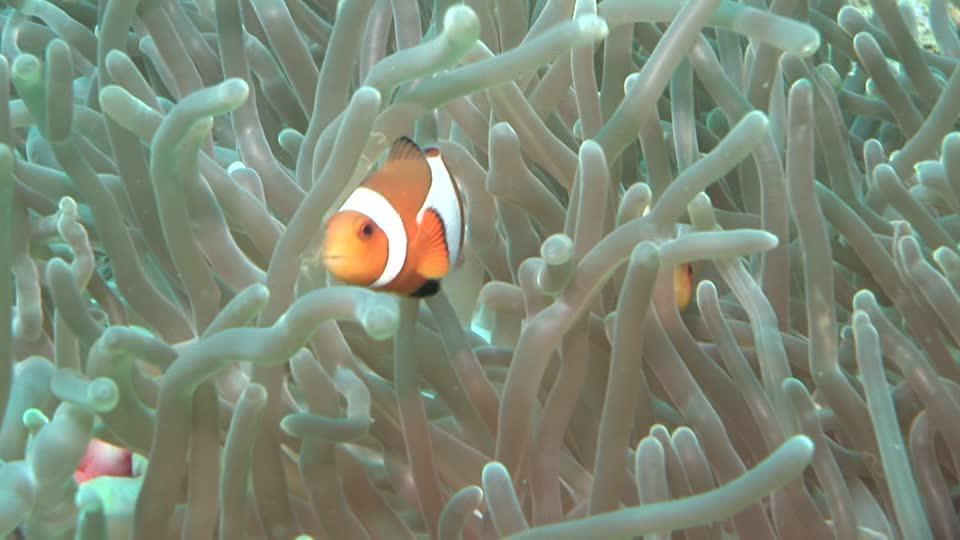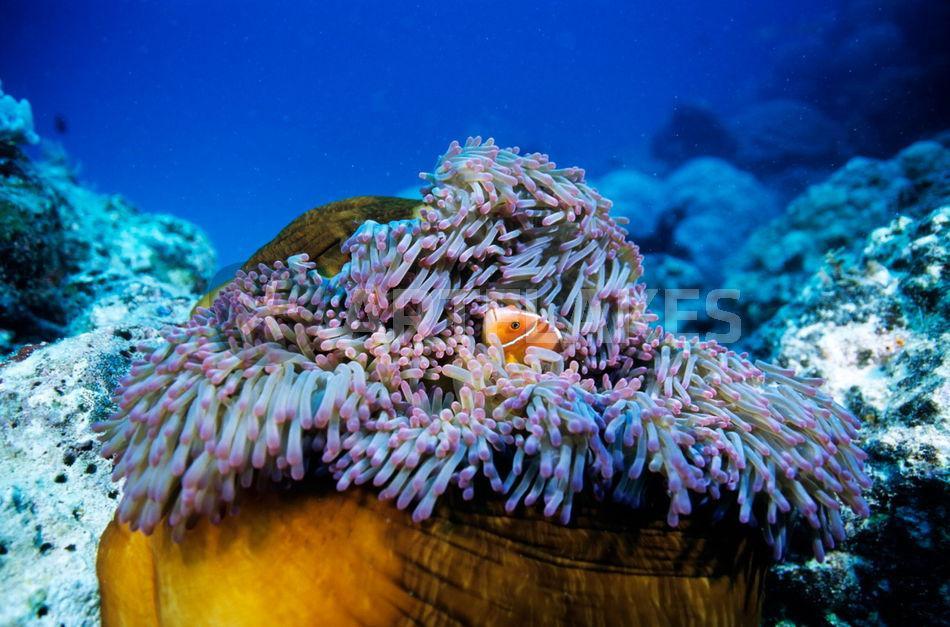The first image is the image on the left, the second image is the image on the right. Assess this claim about the two images: "At least one fish is yellow.". Correct or not? Answer yes or no. No. The first image is the image on the left, the second image is the image on the right. Considering the images on both sides, is "One image shows orange-and-white clownfish swimming among yellowish tendrils, and the other shows white-striped fish with a bright yellow body." valid? Answer yes or no. No. 